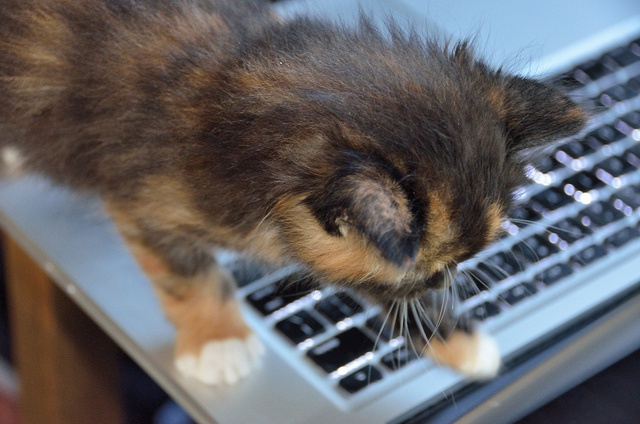Describe the objects in this image and their specific colors. I can see cat in black, gray, and maroon tones, laptop in black, lightblue, darkgray, and gray tones, and keyboard in black, gray, and darkgray tones in this image. 